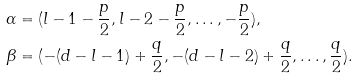<formula> <loc_0><loc_0><loc_500><loc_500>\alpha & = ( l - 1 - \frac { p } { 2 } , l - 2 - \frac { p } { 2 } , \dots , - \frac { p } { 2 } ) , \\ \beta & = ( - ( d - l - 1 ) + \frac { q } { 2 } , - ( d - l - 2 ) + \frac { q } { 2 } , \dots , \frac { q } { 2 } ) .</formula> 